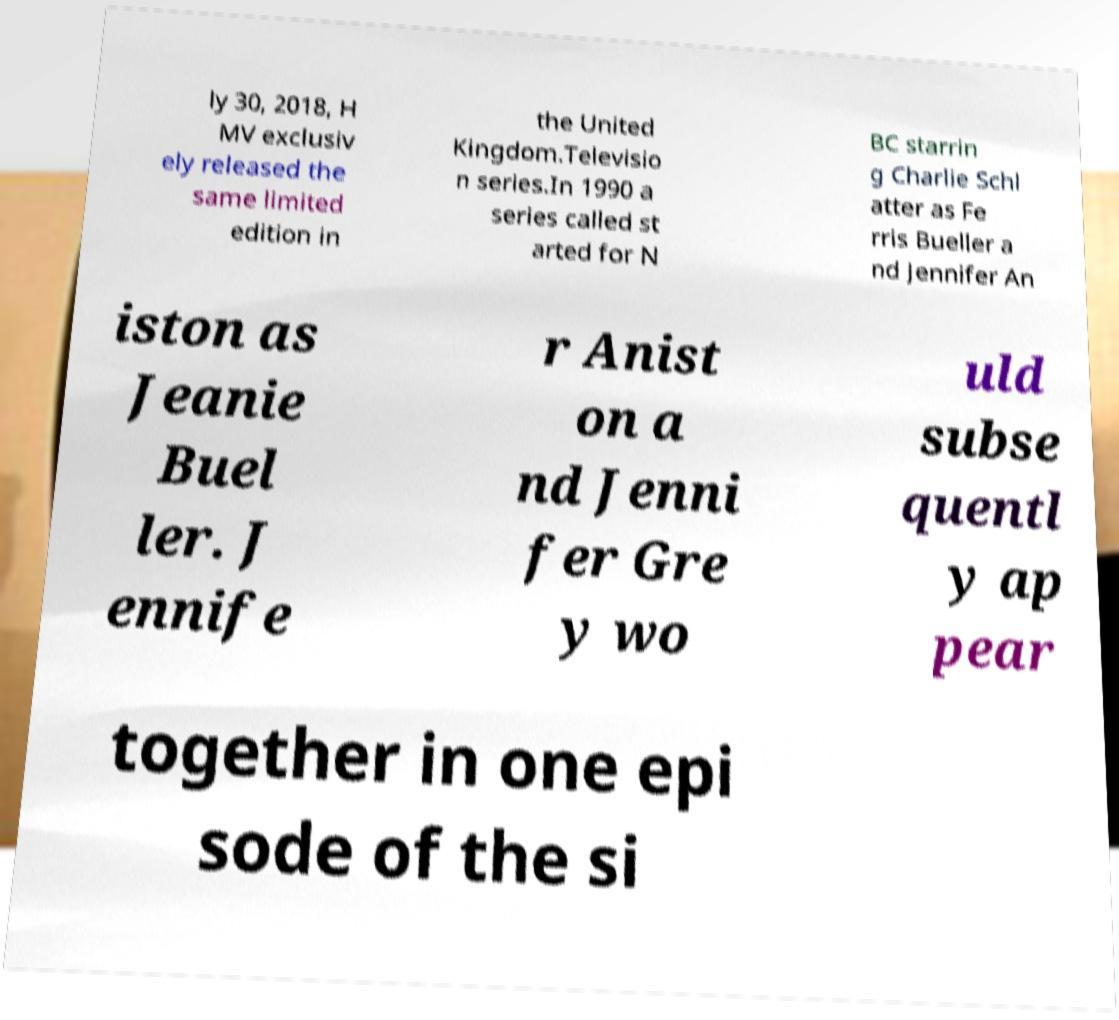Please identify and transcribe the text found in this image. ly 30, 2018, H MV exclusiv ely released the same limited edition in the United Kingdom.Televisio n series.In 1990 a series called st arted for N BC starrin g Charlie Schl atter as Fe rris Bueller a nd Jennifer An iston as Jeanie Buel ler. J ennife r Anist on a nd Jenni fer Gre y wo uld subse quentl y ap pear together in one epi sode of the si 